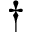Convert formula to latex. <formula><loc_0><loc_0><loc_500><loc_500>^ { \dagger }</formula> 